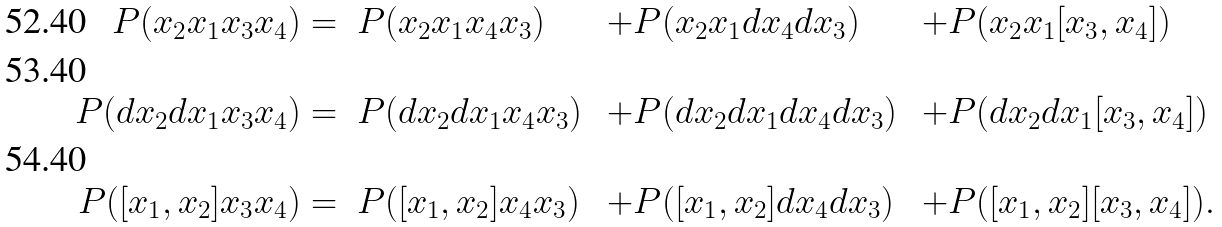<formula> <loc_0><loc_0><loc_500><loc_500>P ( x _ { 2 } x _ { 1 } x _ { 3 } x _ { 4 } ) & = \ P ( x _ { 2 } x _ { 1 } x _ { 4 } x _ { 3 } ) & + P & ( x _ { 2 } x _ { 1 } d x _ { 4 } d x _ { 3 } ) & + P & ( x _ { 2 } x _ { 1 } [ x _ { 3 } , x _ { 4 } ] ) \\ P ( d x _ { 2 } d x _ { 1 } x _ { 3 } x _ { 4 } ) & = \ P ( d x _ { 2 } d x _ { 1 } x _ { 4 } x _ { 3 } ) & + P & ( d x _ { 2 } d x _ { 1 } d x _ { 4 } d x _ { 3 } ) & + P & ( d x _ { 2 } d x _ { 1 } [ x _ { 3 } , x _ { 4 } ] ) \\ P ( [ x _ { 1 } , x _ { 2 } ] x _ { 3 } x _ { 4 } ) & = \ P ( [ x _ { 1 } , x _ { 2 } ] x _ { 4 } x _ { 3 } ) & + P & ( [ x _ { 1 } , x _ { 2 } ] d x _ { 4 } d x _ { 3 } ) & + P & ( [ x _ { 1 } , x _ { 2 } ] [ x _ { 3 } , x _ { 4 } ] ) .</formula> 